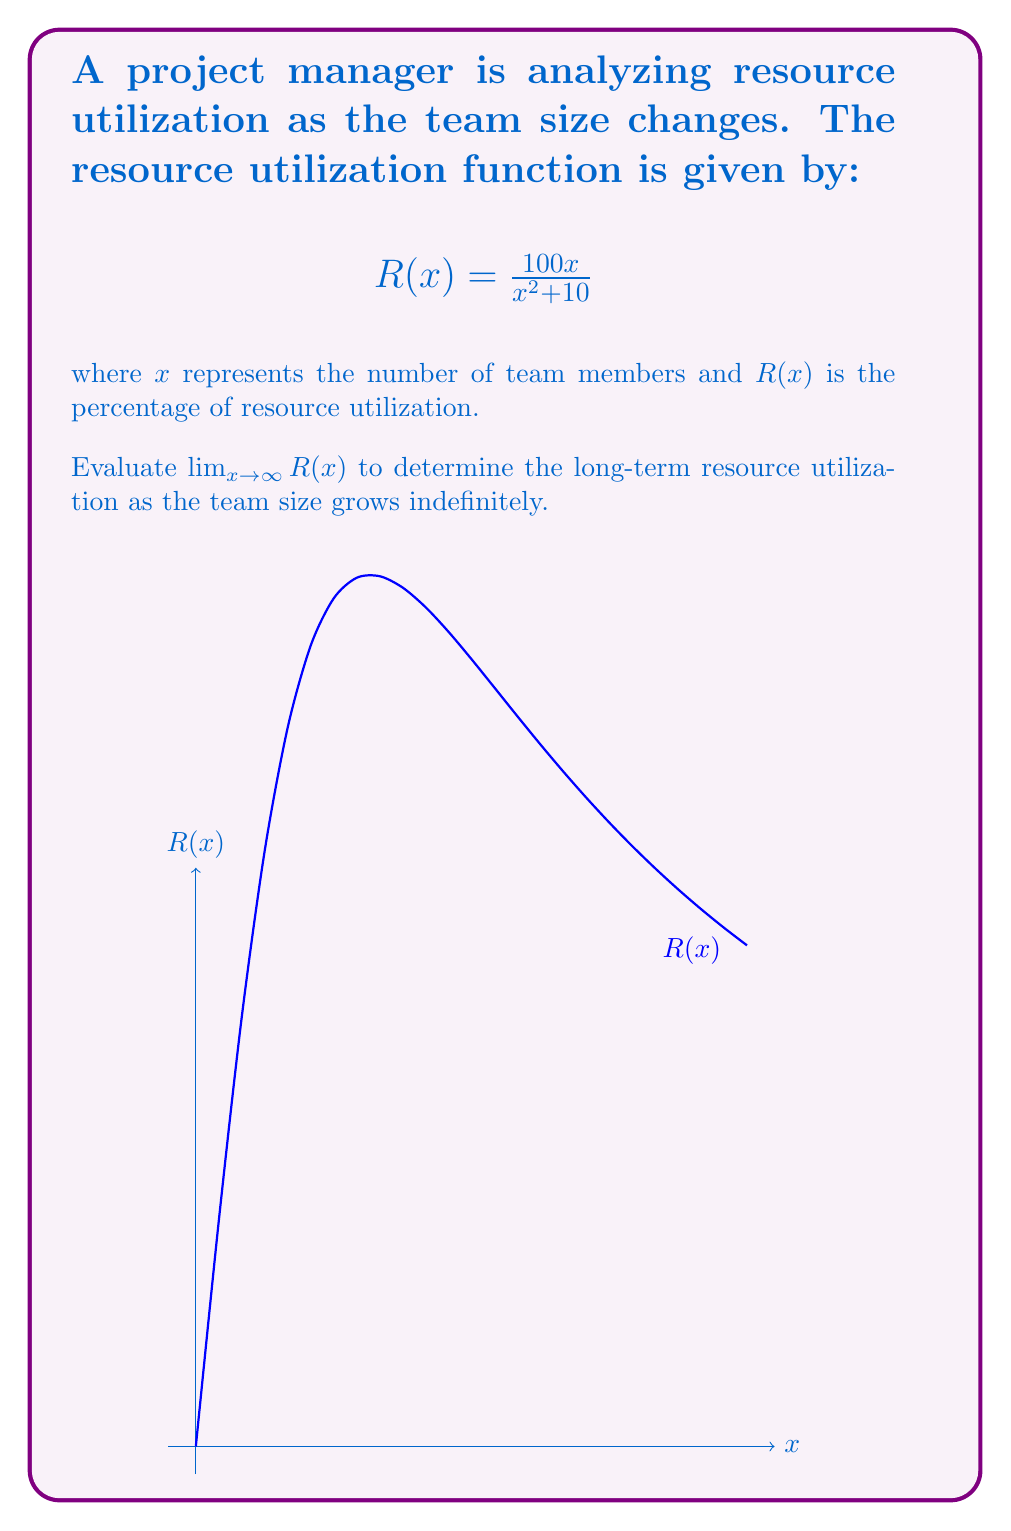Help me with this question. To evaluate $\lim_{x \to \infty} R(x)$, we'll follow these steps:

1) First, let's examine the function:
   $$R(x) = \frac{100x}{x^2 + 10}$$

2) To find the limit as x approaches infinity, we can divide both numerator and denominator by the highest power of x in the denominator, which is $x^2$:

   $$\lim_{x \to \infty} R(x) = \lim_{x \to \infty} \frac{100x}{x^2 + 10} = \lim_{x \to \infty} \frac{100x/x^2}{(x^2 + 10)/x^2}$$

3) Simplify:
   $$\lim_{x \to \infty} \frac{100/x}{1 + 10/x^2}$$

4) As $x$ approaches infinity:
   - $1/x$ approaches 0
   - $1/x^2$ approaches 0 even faster

5) Therefore:
   $$\lim_{x \to \infty} \frac{100/x}{1 + 10/x^2} = \frac{0}{1 + 0} = 0$$

This means that as the team size grows indefinitely, the resource utilization approaches 0%.
Answer: 0 